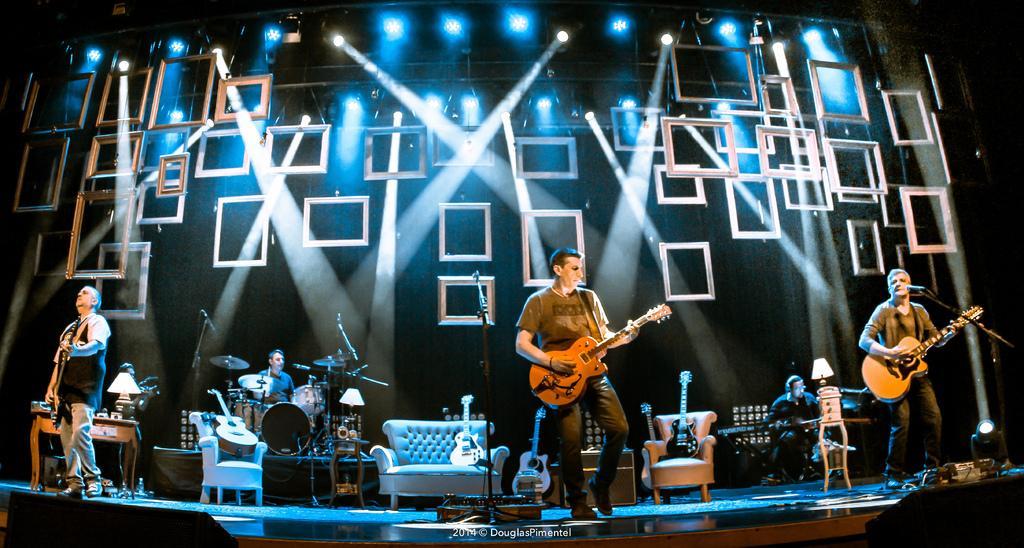How would you summarize this image in a sentence or two? In this image I can see few people playing a musical instruments. There is a mic and a stand. At the back side there is a couch,table,lamp. 